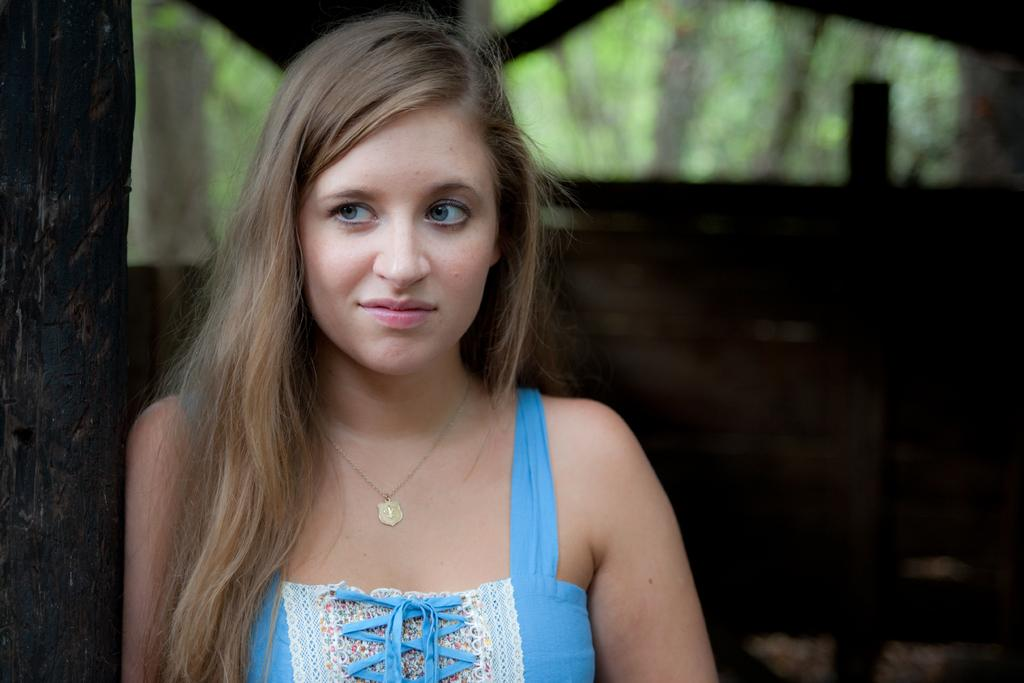Who is the main subject in the foreground of the image? There is a lady in the foreground of the image. What type of wall can be seen in the background of the image? There is a wooden wall in the background of the image. What natural elements are visible in the image? Trees are visible in the image. What type of animal can be seen bursting through the wooden wall in the image? There is no animal present in the image, nor is there any indication of something bursting through the wooden wall. 